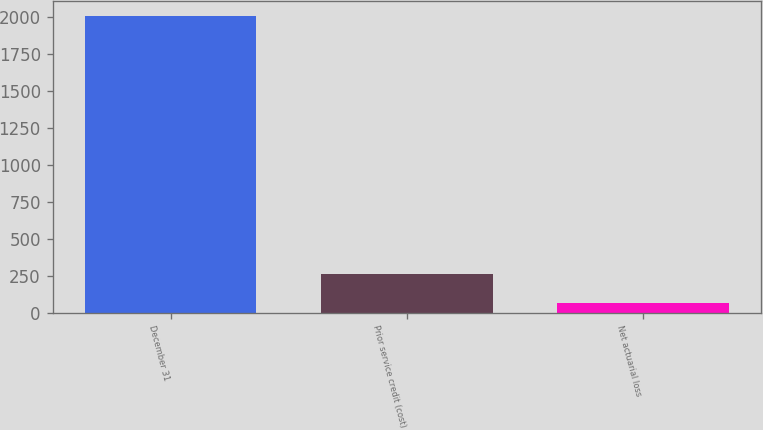Convert chart to OTSL. <chart><loc_0><loc_0><loc_500><loc_500><bar_chart><fcel>December 31<fcel>Prior service credit (cost)<fcel>Net actuarial loss<nl><fcel>2009<fcel>260.3<fcel>66<nl></chart> 